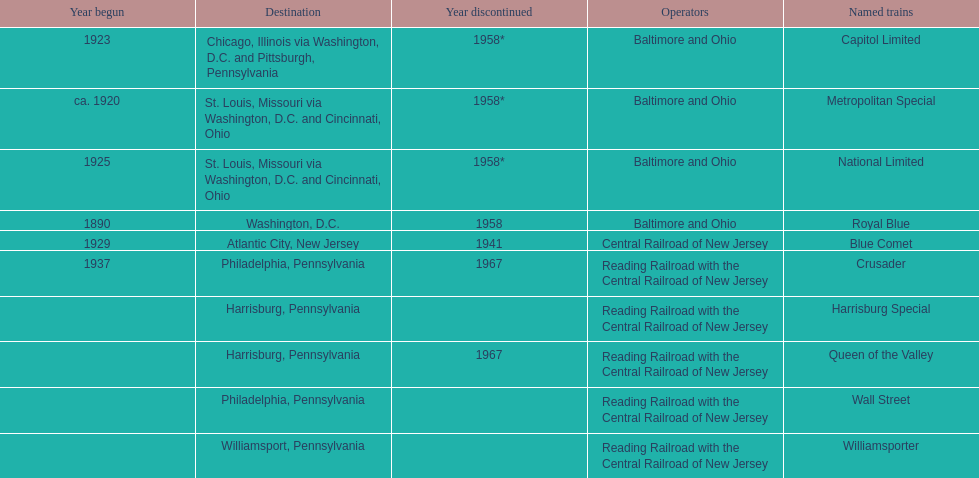How many trains were discontinued in 1958? 4. 